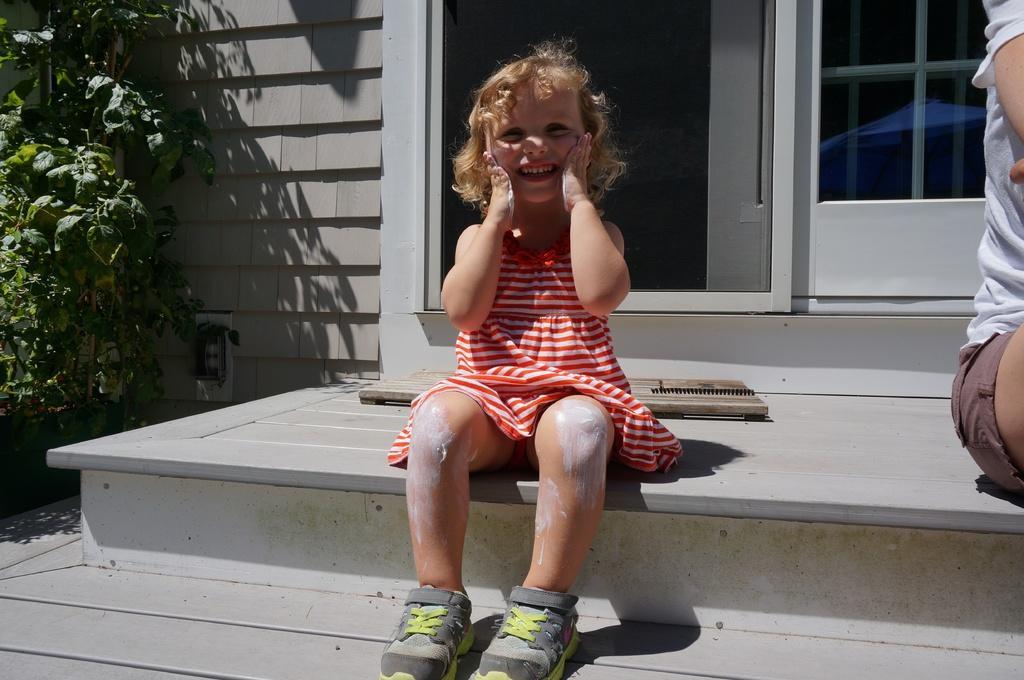Can you describe this image briefly? In this image we can see a kid wearing red color dress, black color shoes sitting on floor, on right side of the image there is a person's body, on left side of the image there is a plant and in the background of the image there is a wall and door. 